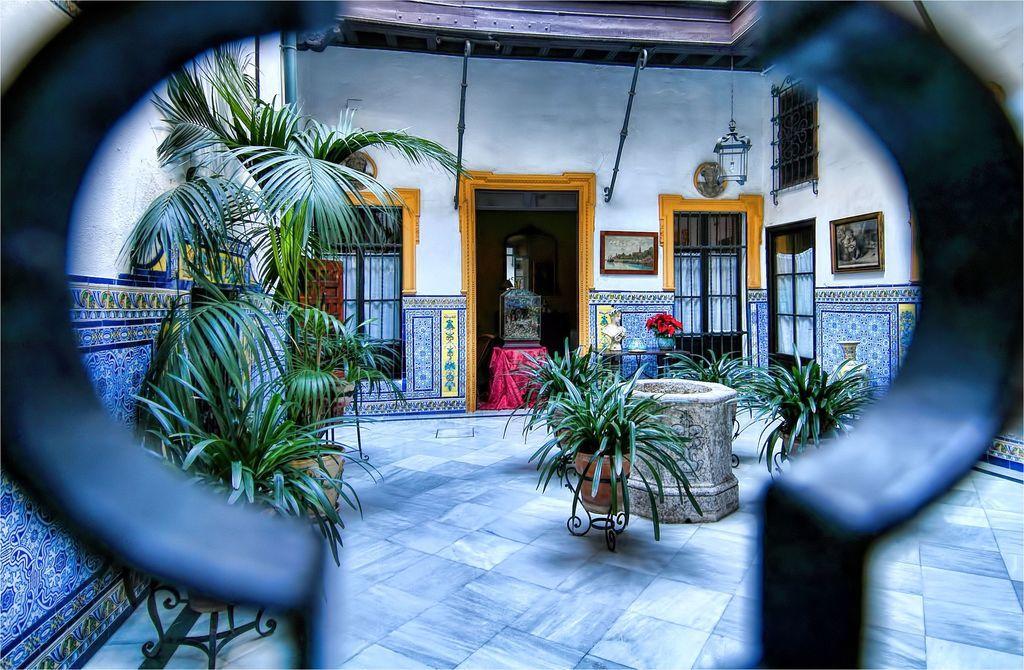Could you give a brief overview of what you see in this image? In this image we can see a house. There is door. There are windows. There are plants at the center of the image. To the left side of the image there is a wall. In the foreground of the image there is a metal railing. At the bottom of the image there is a floor. 